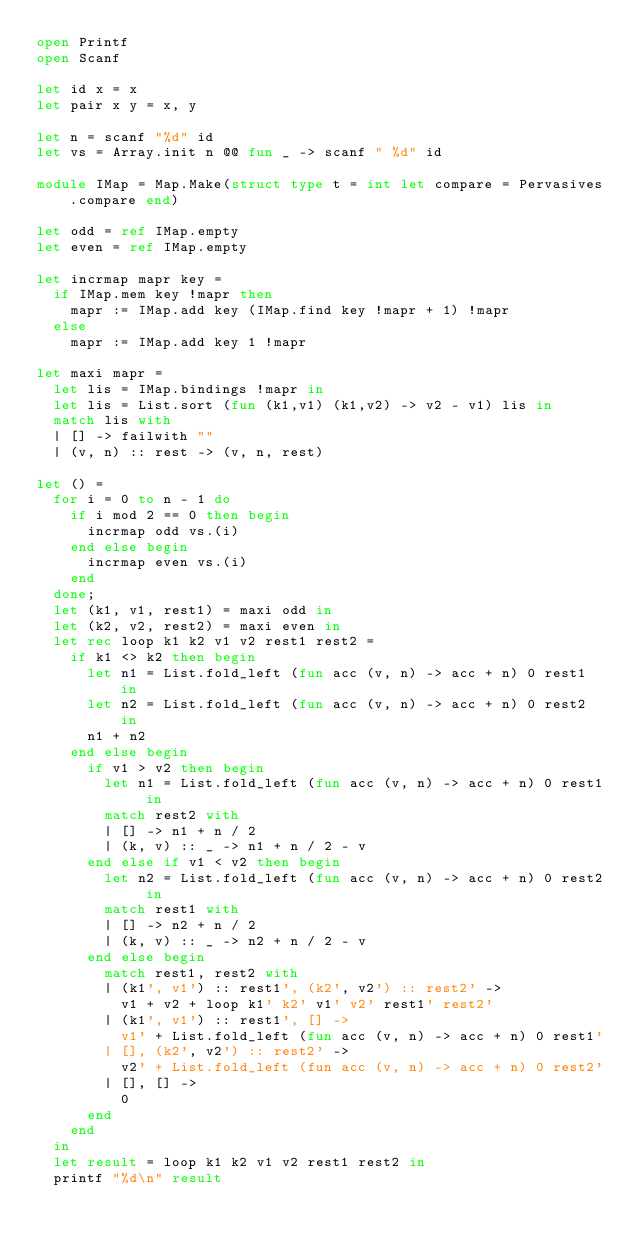<code> <loc_0><loc_0><loc_500><loc_500><_OCaml_>open Printf
open Scanf

let id x = x
let pair x y = x, y

let n = scanf "%d" id
let vs = Array.init n @@ fun _ -> scanf " %d" id

module IMap = Map.Make(struct type t = int let compare = Pervasives.compare end)

let odd = ref IMap.empty
let even = ref IMap.empty

let incrmap mapr key =
  if IMap.mem key !mapr then
    mapr := IMap.add key (IMap.find key !mapr + 1) !mapr
  else
    mapr := IMap.add key 1 !mapr

let maxi mapr =
  let lis = IMap.bindings !mapr in
  let lis = List.sort (fun (k1,v1) (k1,v2) -> v2 - v1) lis in
  match lis with
  | [] -> failwith ""
  | (v, n) :: rest -> (v, n, rest)

let () =
  for i = 0 to n - 1 do
    if i mod 2 == 0 then begin
      incrmap odd vs.(i)
    end else begin
      incrmap even vs.(i)
    end
  done;
  let (k1, v1, rest1) = maxi odd in
  let (k2, v2, rest2) = maxi even in
  let rec loop k1 k2 v1 v2 rest1 rest2 =
    if k1 <> k2 then begin
      let n1 = List.fold_left (fun acc (v, n) -> acc + n) 0 rest1 in
      let n2 = List.fold_left (fun acc (v, n) -> acc + n) 0 rest2 in
      n1 + n2
    end else begin
      if v1 > v2 then begin
        let n1 = List.fold_left (fun acc (v, n) -> acc + n) 0 rest1 in
        match rest2 with
        | [] -> n1 + n / 2
        | (k, v) :: _ -> n1 + n / 2 - v
      end else if v1 < v2 then begin
        let n2 = List.fold_left (fun acc (v, n) -> acc + n) 0 rest2 in
        match rest1 with
        | [] -> n2 + n / 2
        | (k, v) :: _ -> n2 + n / 2 - v
      end else begin
        match rest1, rest2 with
        | (k1', v1') :: rest1', (k2', v2') :: rest2' ->
          v1 + v2 + loop k1' k2' v1' v2' rest1' rest2'
        | (k1', v1') :: rest1', [] ->
          v1' + List.fold_left (fun acc (v, n) -> acc + n) 0 rest1'
        | [], (k2', v2') :: rest2' ->
          v2' + List.fold_left (fun acc (v, n) -> acc + n) 0 rest2'
        | [], [] ->
          0
      end
    end
  in
  let result = loop k1 k2 v1 v2 rest1 rest2 in
  printf "%d\n" result
</code> 